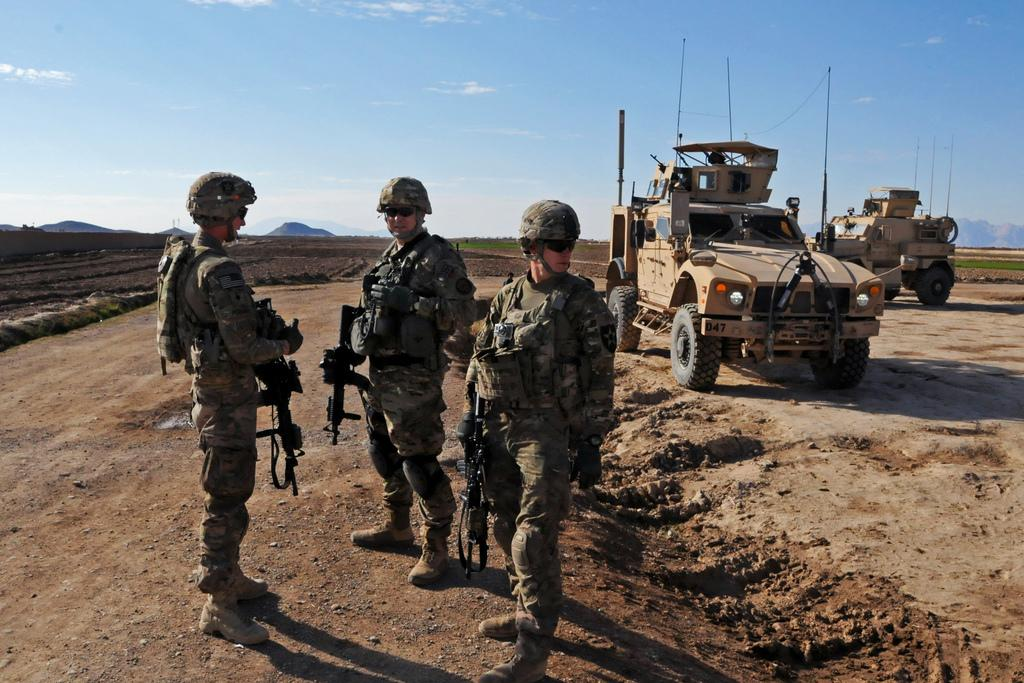What are the persons in the image holding? The persons in the image are holding guns. What can be seen on the right side of the image? There is a vehicle on the right side of the image. What type of landscape is visible in the background of the image? There are hills visible in the background of the image. What is at the bottom of the image? There is ground at the bottom of the image. What color is the silver bead on the sheet in the image? There is no silver bead or sheet present in the image. 